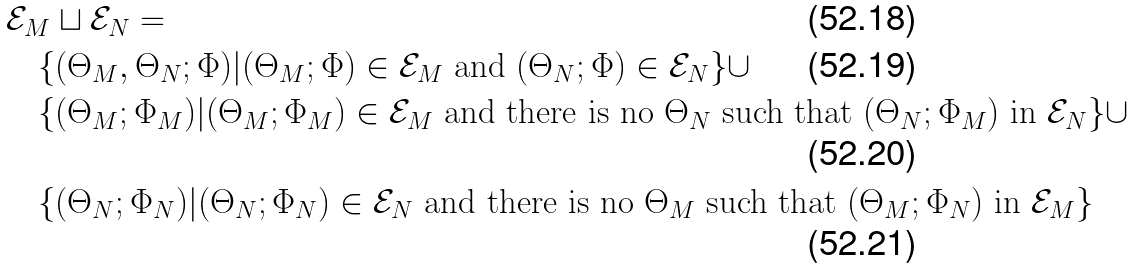<formula> <loc_0><loc_0><loc_500><loc_500>& { \mathcal { E } } _ { M } \sqcup { \mathcal { E } } _ { N } = \\ & \quad \{ ( \Theta _ { M } , \Theta _ { N } ; \Phi ) | ( \Theta _ { M } ; \Phi ) \in { \mathcal { E } } _ { M } \text { and } ( \Theta _ { N } ; \Phi ) \in { \mathcal { E } } _ { N } \} \cup \\ & \quad \{ ( \Theta _ { M } ; \Phi _ { M } ) | ( \Theta _ { M } ; \Phi _ { M } ) \in { \mathcal { E } } _ { M } \text { and there is no } \Theta _ { N } \text { such that } ( \Theta _ { N } ; \Phi _ { M } ) \text { in } { \mathcal { E } } _ { N } \} \cup \\ & \quad \{ ( \Theta _ { N } ; \Phi _ { N } ) | ( \Theta _ { N } ; \Phi _ { N } ) \in { \mathcal { E } } _ { N } \text { and there is no } \Theta _ { M } \text { such that } ( \Theta _ { M } ; \Phi _ { N } ) \text { in } { \mathcal { E } } _ { M } \}</formula> 